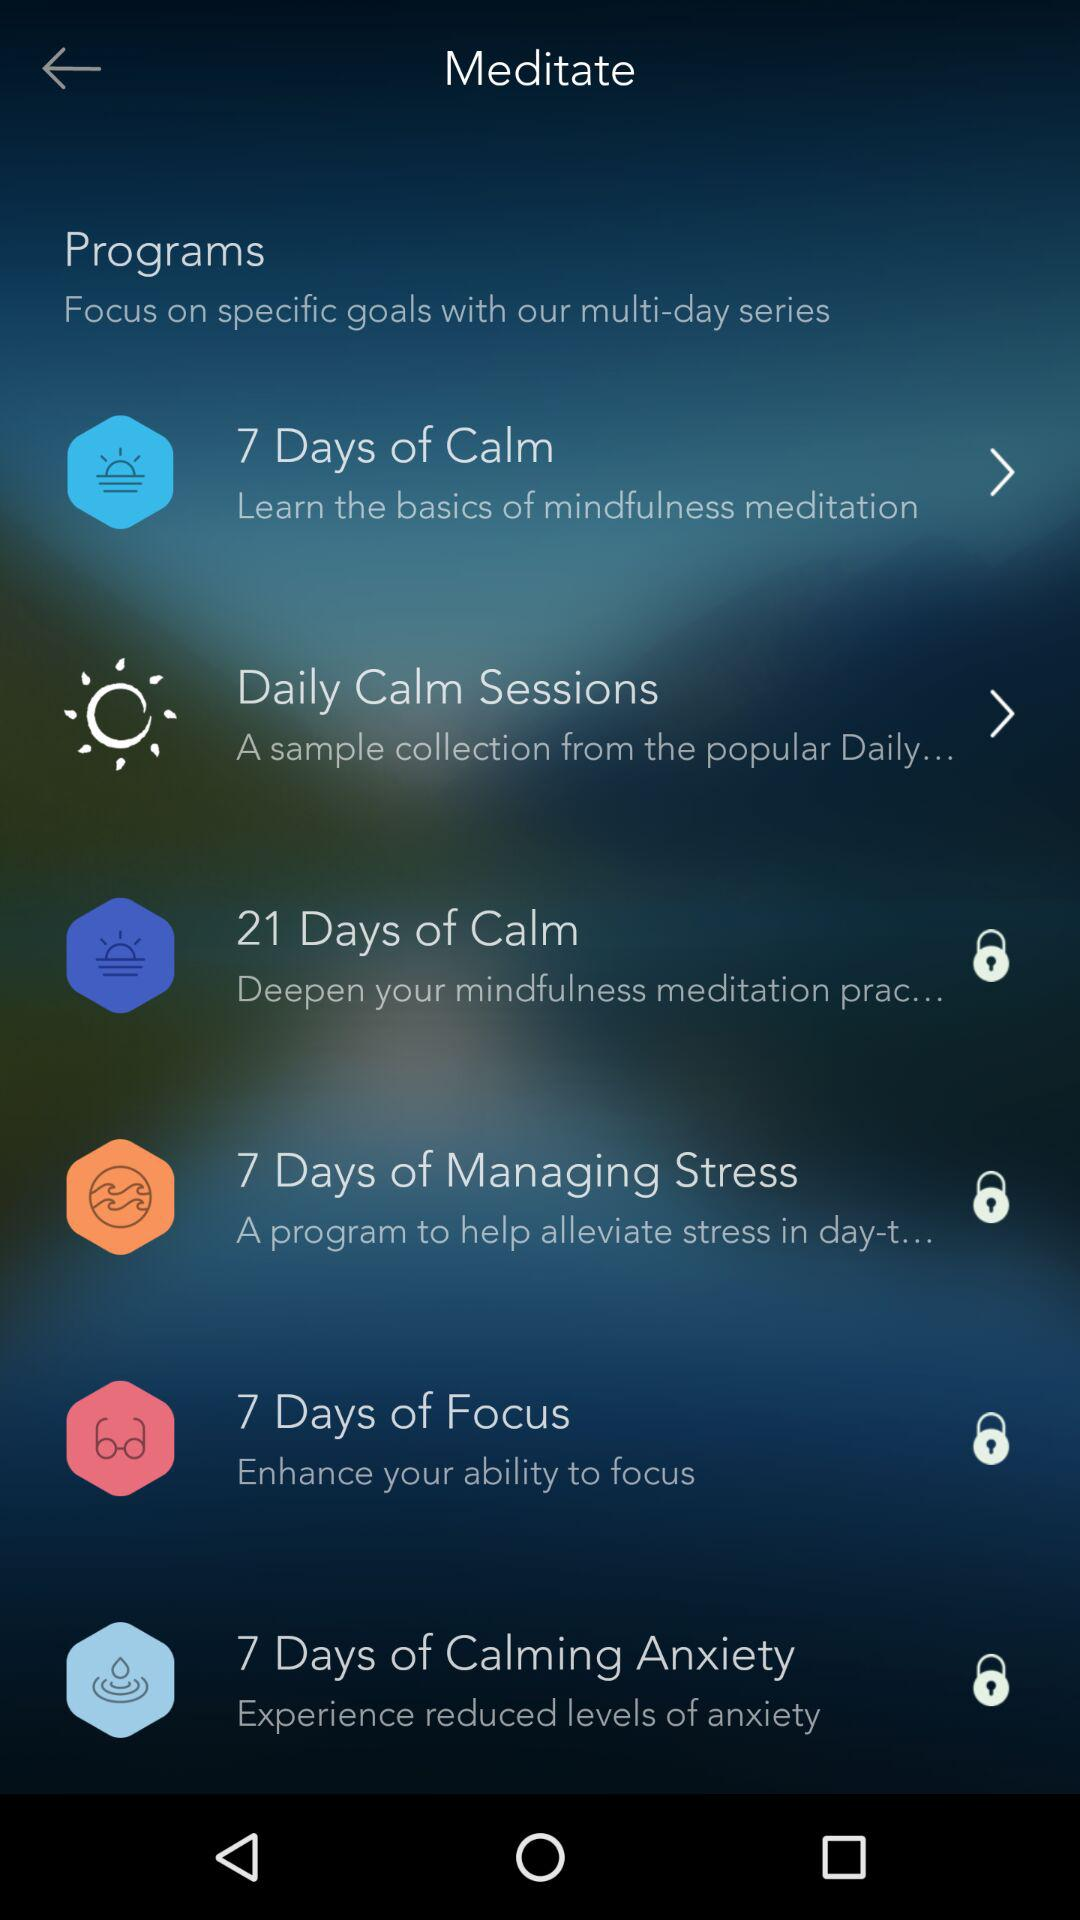How many programs are there?
Answer the question using a single word or phrase. 6 